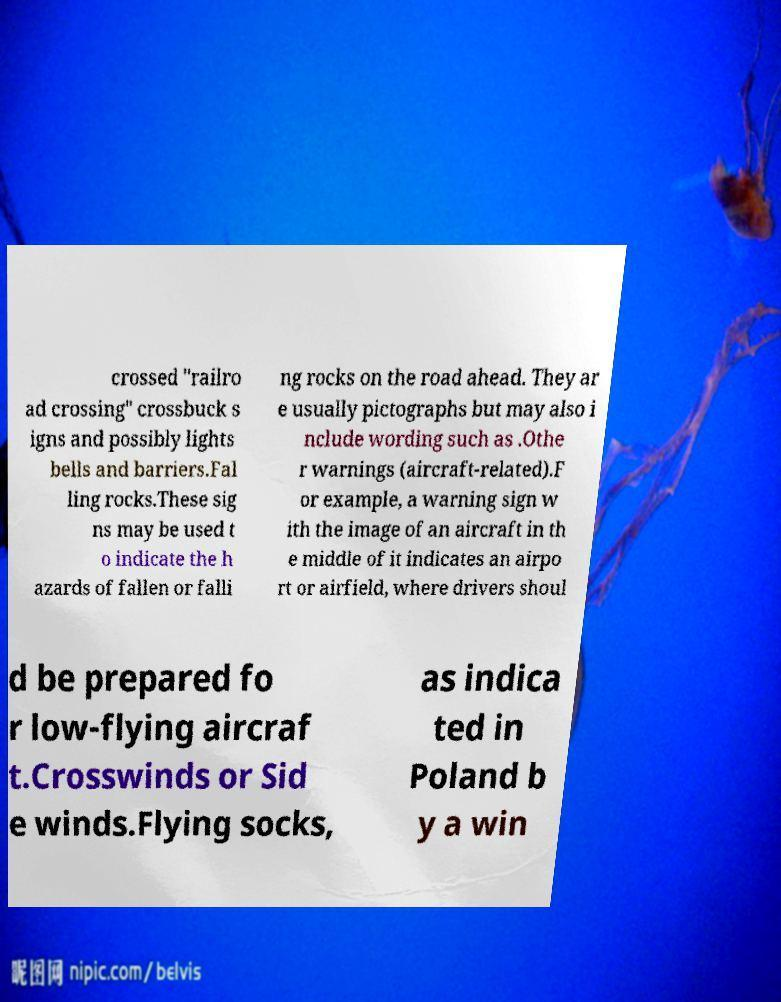Could you assist in decoding the text presented in this image and type it out clearly? crossed "railro ad crossing" crossbuck s igns and possibly lights bells and barriers.Fal ling rocks.These sig ns may be used t o indicate the h azards of fallen or falli ng rocks on the road ahead. They ar e usually pictographs but may also i nclude wording such as .Othe r warnings (aircraft-related).F or example, a warning sign w ith the image of an aircraft in th e middle of it indicates an airpo rt or airfield, where drivers shoul d be prepared fo r low-flying aircraf t.Crosswinds or Sid e winds.Flying socks, as indica ted in Poland b y a win 